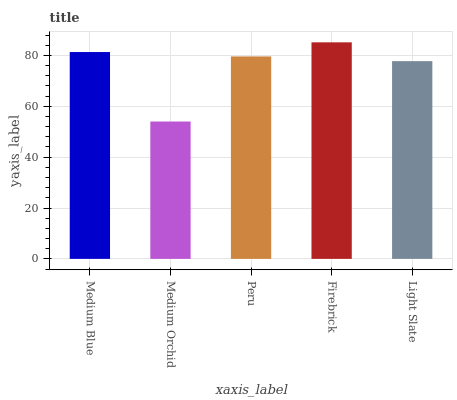Is Medium Orchid the minimum?
Answer yes or no. Yes. Is Firebrick the maximum?
Answer yes or no. Yes. Is Peru the minimum?
Answer yes or no. No. Is Peru the maximum?
Answer yes or no. No. Is Peru greater than Medium Orchid?
Answer yes or no. Yes. Is Medium Orchid less than Peru?
Answer yes or no. Yes. Is Medium Orchid greater than Peru?
Answer yes or no. No. Is Peru less than Medium Orchid?
Answer yes or no. No. Is Peru the high median?
Answer yes or no. Yes. Is Peru the low median?
Answer yes or no. Yes. Is Medium Orchid the high median?
Answer yes or no. No. Is Light Slate the low median?
Answer yes or no. No. 